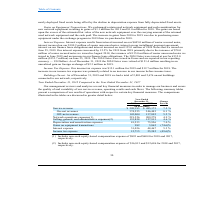From Cogent Communications Group's financial document, What are the respective on-cash equity-based compensation expense included in network operations expenses in 2018 and 2017? The document shows two values: $895 and $604 (in thousands). From the document: "cash equity-based compensation expense of $895 and $604 for 2018 and 2017, respectively. udes non-cash equity-based compensation expense of $895 and $..." Also, What are the respective on-cash equity-based compensation expense included in selling, general, and administrative expenses in 2018 and 2017? The document shows two values: $16,813 and $12,686 (in thousands). From the document: "h equity-based compensation expense of $16,813 and $12,686 for 2018 and 2017, respectively. udes non-cash equity-based compensation expense of $16,813..." Also, What are the respective service revenue earned by the company in 2017 and 2018? The document shows two values: $485,175 and $520,193 (in thousands). From the document: "ercent (in thousands) Service revenue $ 520,193 $ 485,175 7.2 % On - net revenues 374,555 346,445 8.1 % Off - net revenues 145,004 137,892 5.2 % Netwo..." Also, can you calculate: What is the average service revenue earned by the company in 2017 and 2018? To answer this question, I need to perform calculations using the financial data. The calculation is: (485,175 + 520,193)/2 , which equals 502684 (in thousands). This is based on the information: "ercent (in thousands) Service revenue $ 520,193 $ 485,175 7.2 % On - net revenues 374,555 346,445 8.1 % Off - net revenues 145,004 137,892 5.2 % Network oper 018 2017 Percent (in thousands) Service re..." The key data points involved are: 485,175, 520,193. Also, can you calculate: What is the average on-net revenue earned by the company in 2017 and 2018? To answer this question, I need to perform calculations using the financial data. The calculation is: (346,445 + 374,555)/2 , which equals 360500 (in thousands). This is based on the information: "venue $ 520,193 $ 485,175 7.2 % On - net revenues 374,555 346,445 8.1 % Off - net revenues 145,004 137,892 5.2 % Network operations expenses(1) 219,526 209,2 520,193 $ 485,175 7.2 % On - net revenues ..." The key data points involved are: 346,445, 374,555. Also, can you calculate: What is the average off-net revenue earned by the company in 2017 and 2018? To answer this question, I need to perform calculations using the financial data. The calculation is: (137,892 + 145,004)/2 , which equals 141448 (in thousands). This is based on the information: "374,555 346,445 8.1 % Off - net revenues 145,004 137,892 5.2 % Network operations expenses(1) 219,526 209,278 4.9 % Selling, general, and administrative exp revenues 374,555 346,445 8.1 % Off - net re..." The key data points involved are: 137,892, 145,004. 